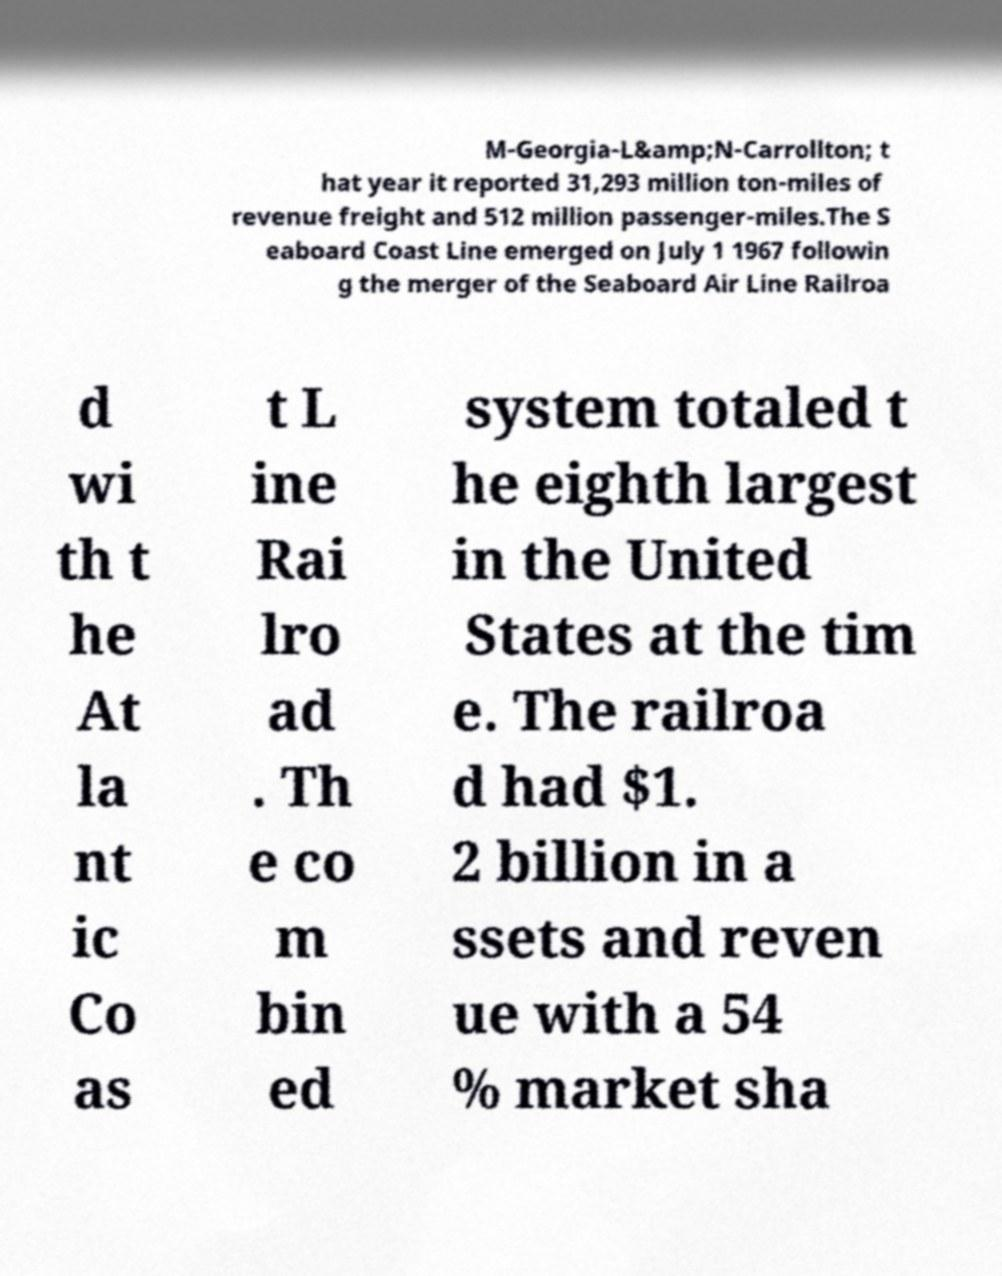There's text embedded in this image that I need extracted. Can you transcribe it verbatim? M-Georgia-L&amp;N-Carrollton; t hat year it reported 31,293 million ton-miles of revenue freight and 512 million passenger-miles.The S eaboard Coast Line emerged on July 1 1967 followin g the merger of the Seaboard Air Line Railroa d wi th t he At la nt ic Co as t L ine Rai lro ad . Th e co m bin ed system totaled t he eighth largest in the United States at the tim e. The railroa d had $1. 2 billion in a ssets and reven ue with a 54 % market sha 